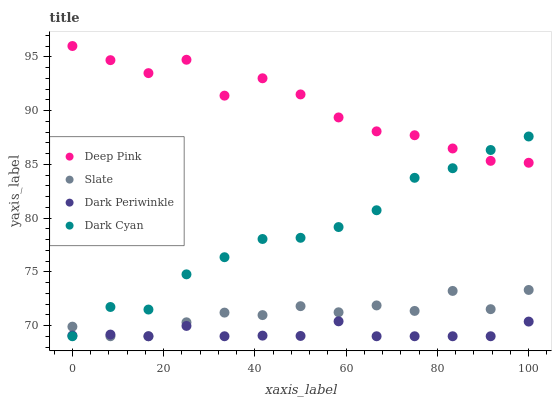Does Dark Periwinkle have the minimum area under the curve?
Answer yes or no. Yes. Does Deep Pink have the maximum area under the curve?
Answer yes or no. Yes. Does Slate have the minimum area under the curve?
Answer yes or no. No. Does Slate have the maximum area under the curve?
Answer yes or no. No. Is Dark Periwinkle the smoothest?
Answer yes or no. Yes. Is Deep Pink the roughest?
Answer yes or no. Yes. Is Slate the smoothest?
Answer yes or no. No. Is Slate the roughest?
Answer yes or no. No. Does Dark Cyan have the lowest value?
Answer yes or no. Yes. Does Deep Pink have the lowest value?
Answer yes or no. No. Does Deep Pink have the highest value?
Answer yes or no. Yes. Does Slate have the highest value?
Answer yes or no. No. Is Dark Periwinkle less than Deep Pink?
Answer yes or no. Yes. Is Deep Pink greater than Slate?
Answer yes or no. Yes. Does Dark Cyan intersect Deep Pink?
Answer yes or no. Yes. Is Dark Cyan less than Deep Pink?
Answer yes or no. No. Is Dark Cyan greater than Deep Pink?
Answer yes or no. No. Does Dark Periwinkle intersect Deep Pink?
Answer yes or no. No. 